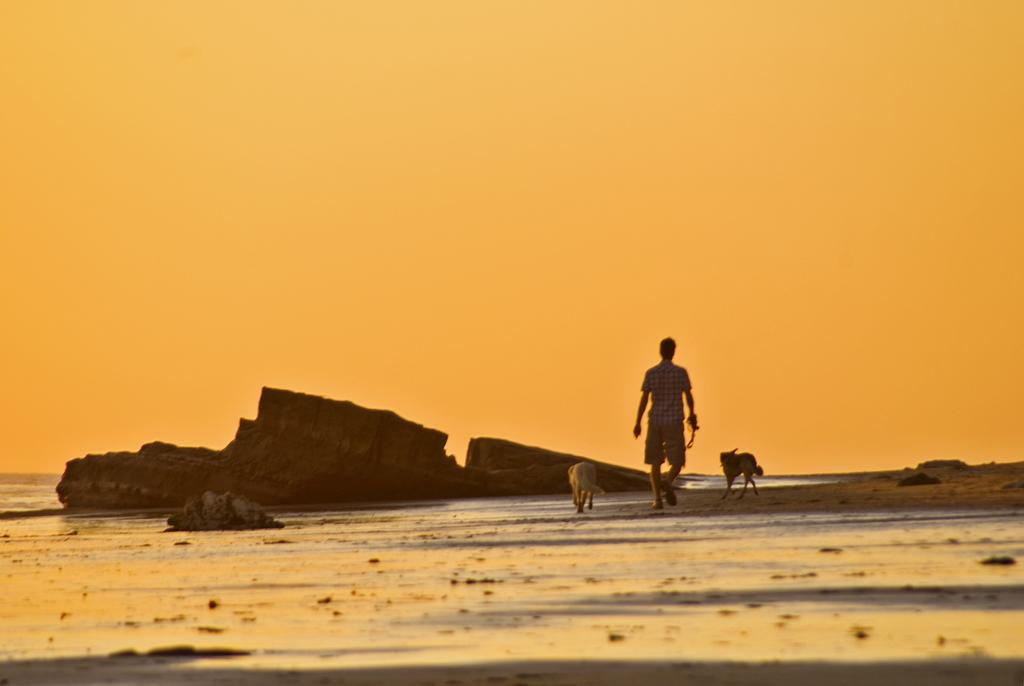What is the man in the image doing? The man is walking in the image. What other living creatures are present in the image? There are animals in the image. What type of objects can be seen on the ground in the image? There are stones in the image. Can you see an airplane flying in the image? No, there is no airplane present in the image. How many quarters are visible on the ground in the image? There are no quarters visible in the image. 